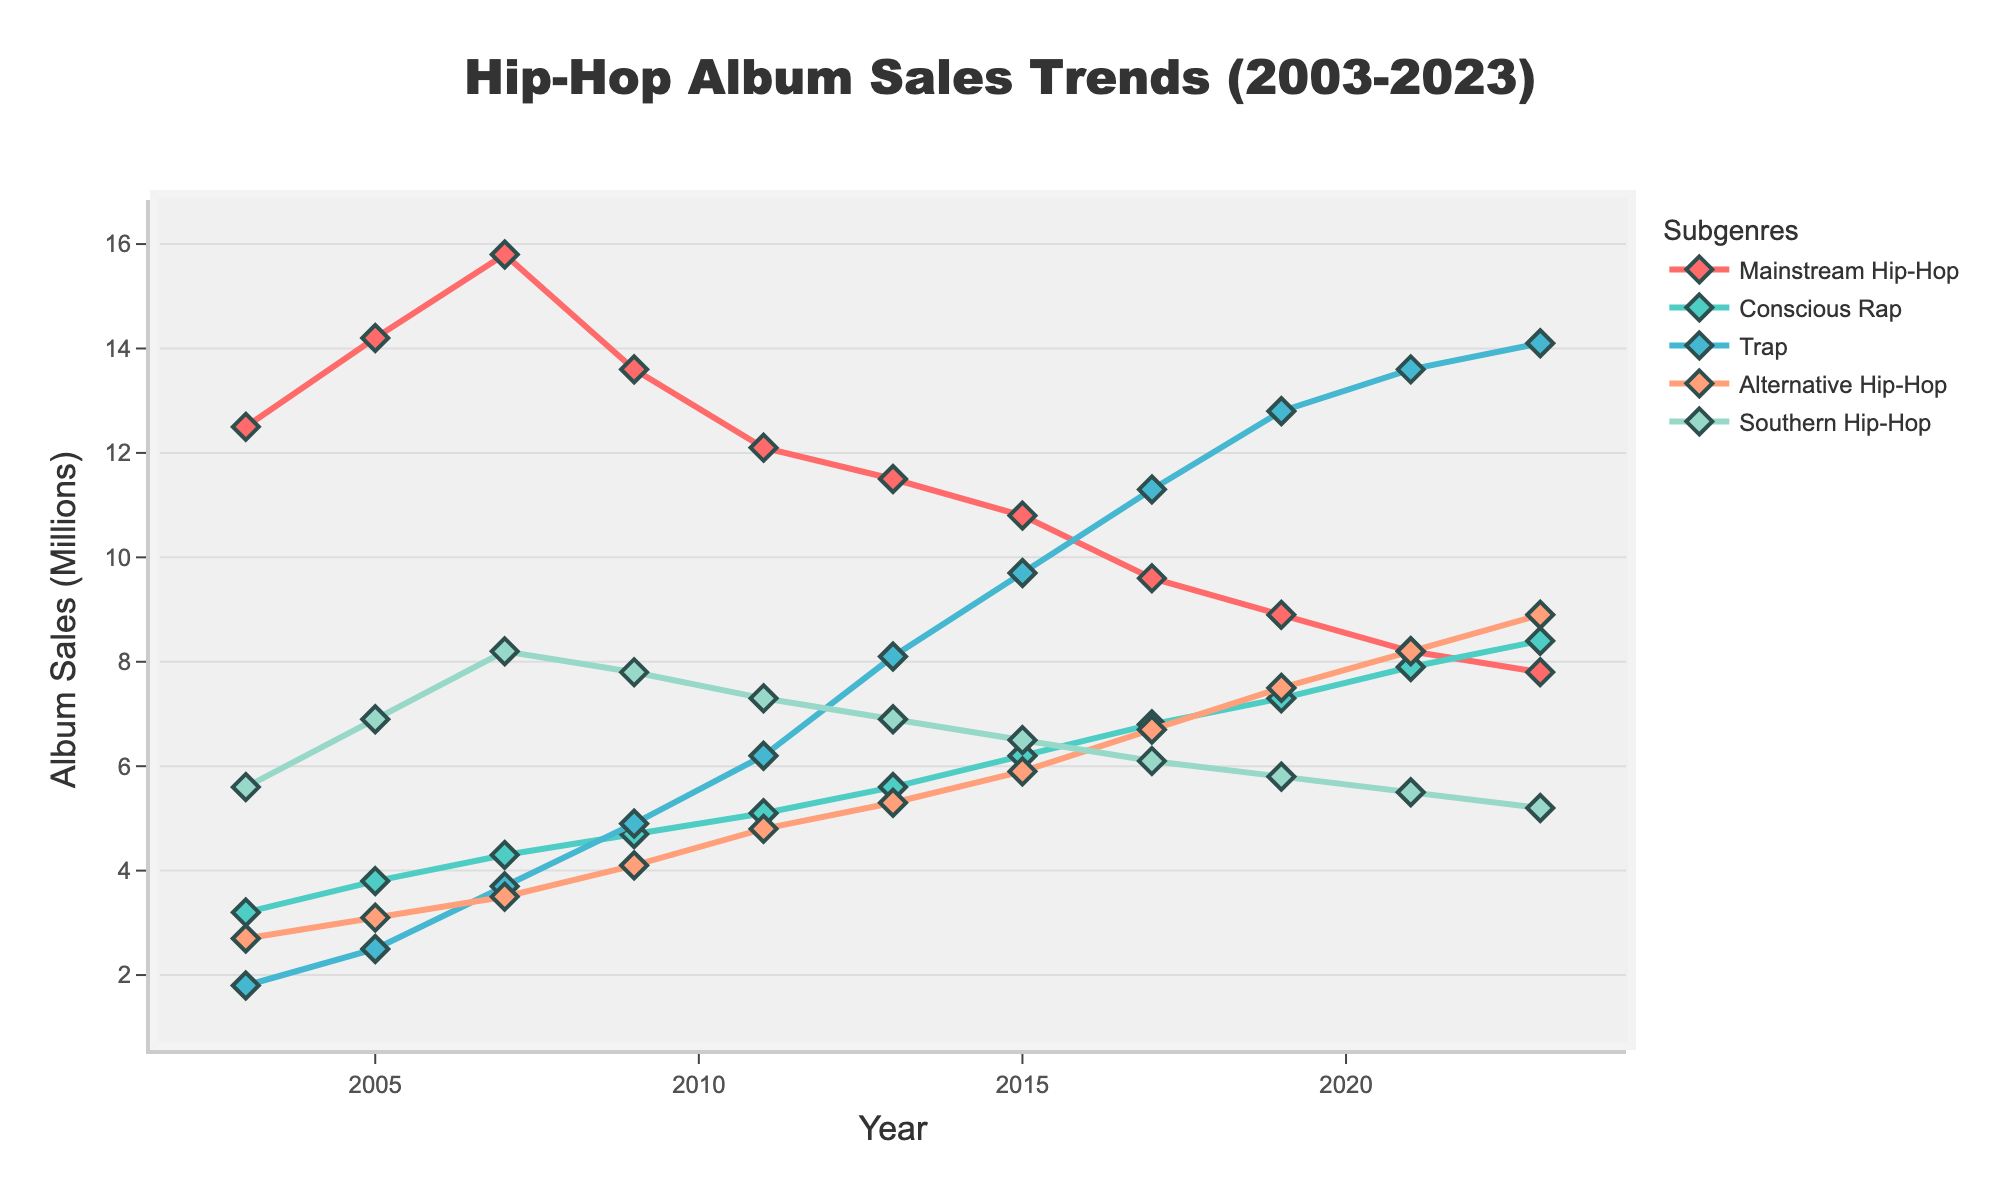Which subgenre had the highest album sales in 2023? To find which subgenre had the highest album sales in 2023, we need to locate the data points for each subgenre for that year and compare their values. According to the chart, Trap had the highest value with 14.1 million sales.
Answer: Trap Which subgenre has shown the most consistent growth over the two decades? By visually examining the trends, we can see that Conscious Rap has shown a consistent upward trajectory from 3.2 million in 2003 to 8.4 million in 2023, without any noticeable declines, indicating the most consistent growth.
Answer: Conscious Rap How do the 2023 album sales of Mainstream Hip-Hop and Alternative Hip-Hop compare? To compare the 2023 album sales of these two subgenres, check their respective values on the y-axis for that year. Mainstream Hip-Hop had 7.8 million sales, and Alternative Hip-Hop had 8.9 million sales. Therefore, Alternative Hip-Hop had more sales than Mainstream Hip-Hop in 2023.
Answer: Alternative Hip-Hop > Mainstream Hip-Hop What is the difference in album sales between Mainstream Hip-Hop and Trap in 2017? First, find the album sales for both subgenres in 2017. Mainstream Hip-Hop had 9.6 million sales, while Trap had 11.3 million sales. Subtract the album sales of Mainstream Hip-Hop from Trap to find the difference: 11.3 - 9.6 = 1.7 million.
Answer: 1.7 million Which subgenre had the largest decline in album sales from its peak to 2023? Locate the peak album sales for each subgenre and compare the decline to 2023 values. Mainstream Hip-Hop peaked at 15.8 million in 2007 and declined to 7.8 million in 2023, a difference of 8.0 million. This is the largest decline among the subgenres.
Answer: Mainstream Hip-Hop What was the average album sales of Conscious Rap over the two decades? To find the average, sum up Conscious Rap sales for all the given years and then divide by the number of years: (3.2 + 3.8 + 4.3 + 4.7 + 5.1 + 5.6 + 6.2 + 6.8 + 7.3 + 7.9 + 8.4)/11. This equals 63 million / 11 years = 5.73 million.
Answer: 5.73 million Which years did Southern Hip-Hop have higher album sales than Alternative Hip-Hop? Compare the album sales of Southern Hip-Hop and Alternative Hip-Hop for each given year. Southern Hip-Hop sales were higher in 2003 (5.6 vs. 2.7), 2005 (6.9 vs. 3.1), 2007 (8.2 vs. 3.5), 2009 (7.8 vs. 4.1), and 2011 (7.3 vs. 4.8).
Answer: 2003, 2005, 2007, 2009, 2011 What is the total album sales for Trap throughout the entire period? Add up the album sales of Trap from 2003 to 2023: 1.8 + 2.5 + 3.7 + 4.9 + 6.2 + 8.1 + 9.7 + 11.3 + 12.8 + 13.6 + 14.1, which equals 88.7 million.
Answer: 88.7 million 